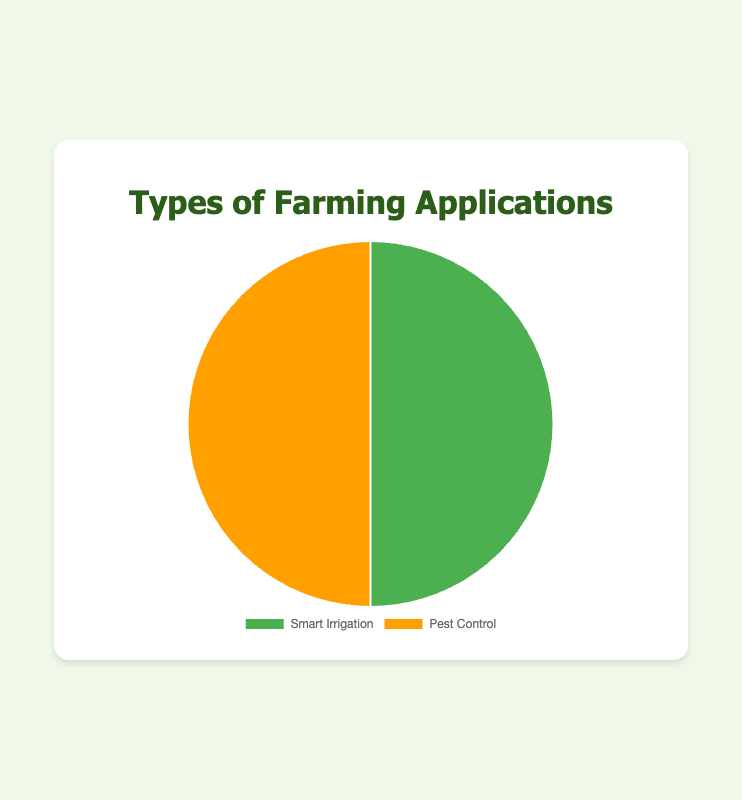Which type of farming application has an equal visual representation in the pie chart? The pie chart shows two sections, "Smart Irrigation" and "Pest Control," each occupying half of the pie. This indicates that both types have equal representation.
Answer: Smart Irrigation and Pest Control Which type of farming application is represented by the yellow section in the pie chart? In the pie chart, the yellow section represents one of the two farming application types. Typically, pie charts use different colors to distinguish segments. Based on typical data visualization conventions, the yellow section is labeled "Pest Control."
Answer: Pest Control What percentage of the pie chart does Smart Irrigation occupy? The pie chart is divided into two equal halves, visually divided evenly between "Smart Irrigation" and "Pest Control." Each segment therefore represents 50% of the entire chart.
Answer: 50% How do the segments "Smart Irrigation" and "Pest Control" compare in size? Both segments of the pie chart are equal in size, suggesting that they occupy the same percentage of the total pie.
Answer: They are equal in size Considering each type of farming application holds 100 points, how does the total number of applications sum up across both categories? Each type of farming application, "Smart Irrigation" and "Pest Control," holds 100 points. To find the total, sum the points: 100 + 100 = 200.
Answer: 200 